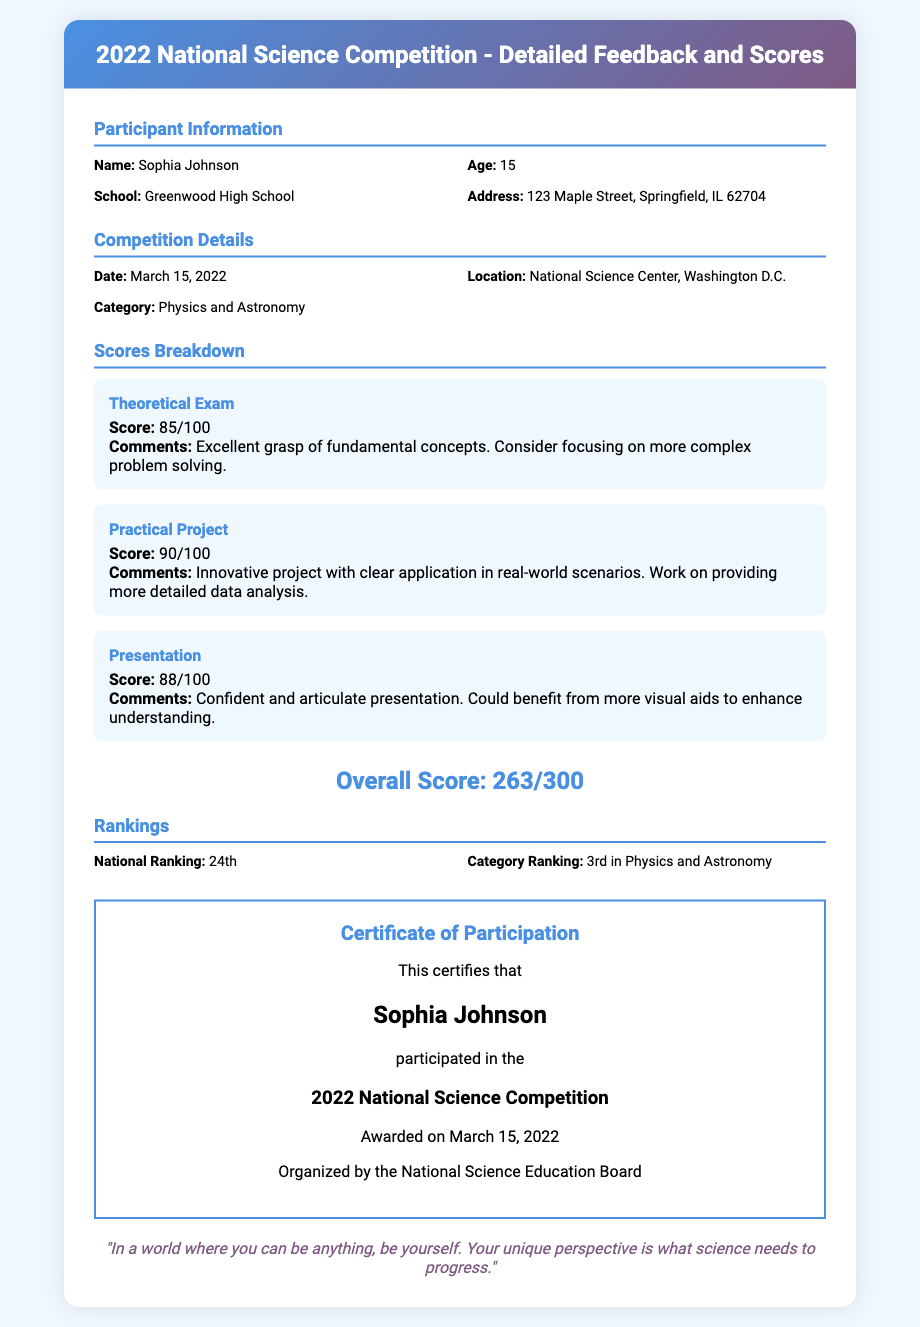What is the name of the participant? The name of the participant is listed in the document under Participant Information.
Answer: Sophia Johnson What is the age of the participant? The age of the participant is mentioned in the information section.
Answer: 15 What date was the competition held? The date can be found in the Competition Details section.
Answer: March 15, 2022 What is the participant's overall score? The overall score is indicated at the end of the Scores Breakdown section.
Answer: 263/300 What position did the participant achieve nationally? The national ranking is specified in the Rankings section.
Answer: 24th What is the category ranking of the participant? The category ranking is provided alongside the national ranking.
Answer: 3rd in Physics and Astronomy What was the score for the practical project? The score for the practical project is provided in the Scores Breakdown section.
Answer: 90/100 What is the title of the certificate? The title of the certificate is specified at the top of the certificate section.
Answer: Certificate of Participation What is the quote included in the document? The quote is stated at the bottom of the content section.
Answer: "In a world where you can be anything, be yourself." 